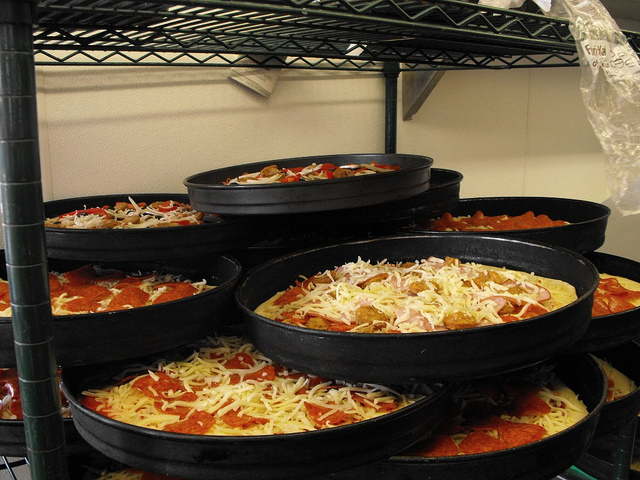What do the visible ingredients on the pizzas tell us about the variety offered? The visible ingredients on the pizzas, ranging from thick layers of cheese and slices of pepperoni to scattered vegetables, suggest a menu that caters to varying tastes. This diverse array hints at a place that aims to offer options from classic, simple toppings to more elaborate, veggie-rich choices, attracting a broad spectrum of pizza lovers. 